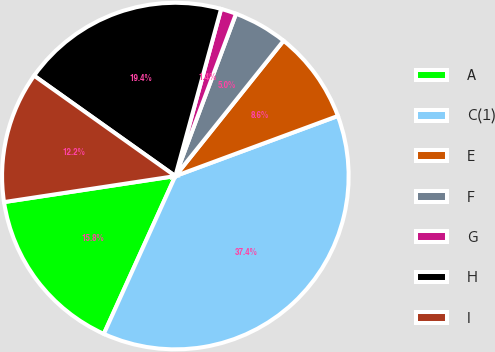Convert chart to OTSL. <chart><loc_0><loc_0><loc_500><loc_500><pie_chart><fcel>A<fcel>C(1)<fcel>E<fcel>F<fcel>G<fcel>H<fcel>I<nl><fcel>15.83%<fcel>37.41%<fcel>8.63%<fcel>5.04%<fcel>1.44%<fcel>19.42%<fcel>12.23%<nl></chart> 